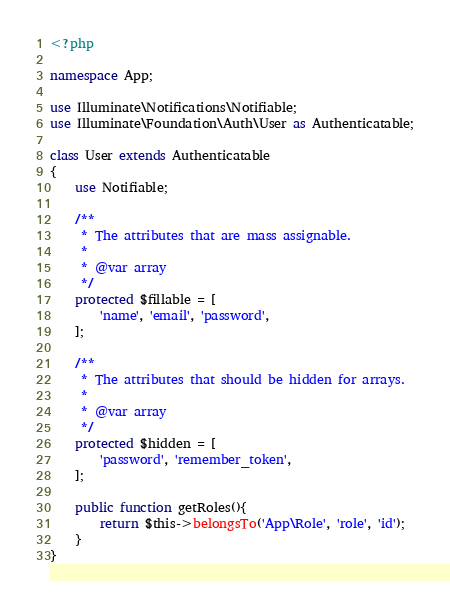Convert code to text. <code><loc_0><loc_0><loc_500><loc_500><_PHP_><?php

namespace App;

use Illuminate\Notifications\Notifiable;
use Illuminate\Foundation\Auth\User as Authenticatable;

class User extends Authenticatable
{
    use Notifiable;

    /**
     * The attributes that are mass assignable.
     *
     * @var array
     */
    protected $fillable = [
        'name', 'email', 'password',
    ];

    /**
     * The attributes that should be hidden for arrays.
     *
     * @var array
     */
    protected $hidden = [
        'password', 'remember_token',
    ];

    public function getRoles(){
        return $this->belongsTo('App\Role', 'role', 'id');
    }
}
</code> 